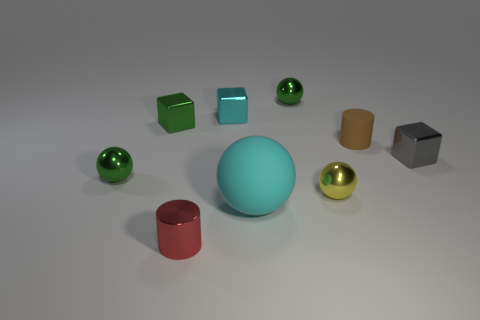Subtract 0 red blocks. How many objects are left? 9 Subtract all cylinders. How many objects are left? 7 Subtract all gray metallic blocks. Subtract all yellow spheres. How many objects are left? 7 Add 1 small gray shiny things. How many small gray shiny things are left? 2 Add 3 small cyan metallic objects. How many small cyan metallic objects exist? 4 